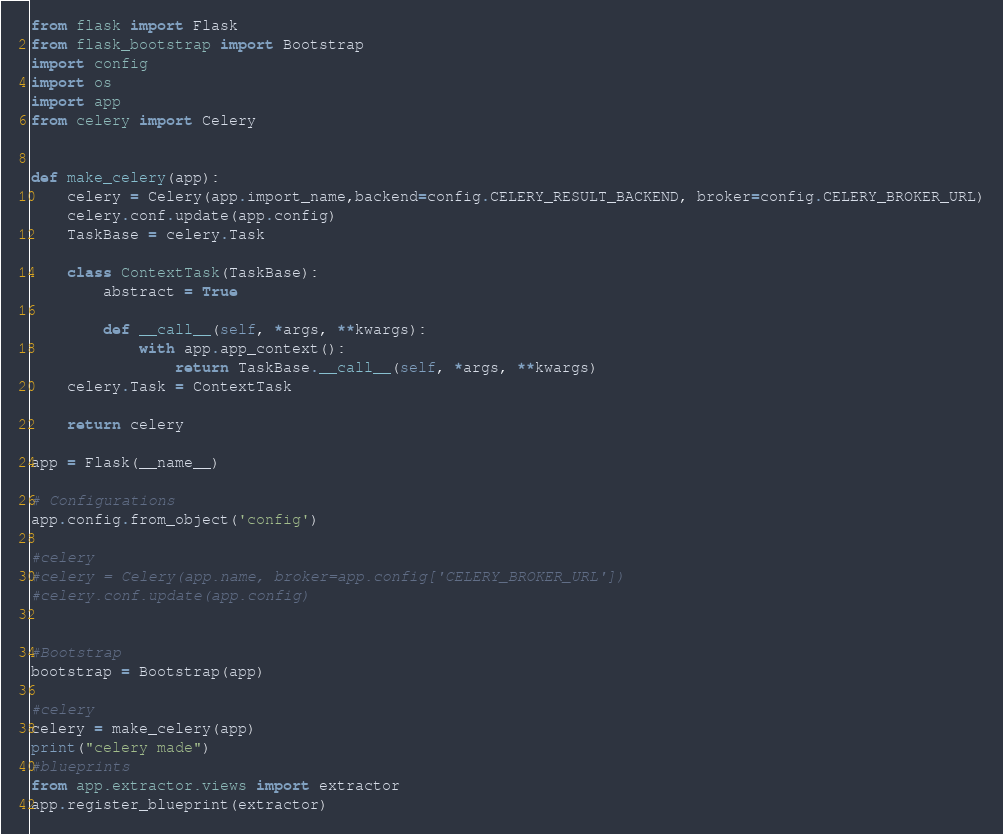Convert code to text. <code><loc_0><loc_0><loc_500><loc_500><_Python_>from flask import Flask
from flask_bootstrap import Bootstrap
import config
import os
import app
from celery import Celery


def make_celery(app):
    celery = Celery(app.import_name,backend=config.CELERY_RESULT_BACKEND, broker=config.CELERY_BROKER_URL)
    celery.conf.update(app.config)
    TaskBase = celery.Task

    class ContextTask(TaskBase):
        abstract = True

        def __call__(self, *args, **kwargs):
            with app.app_context():
                return TaskBase.__call__(self, *args, **kwargs)
    celery.Task = ContextTask

    return celery

app = Flask(__name__)

# Configurations
app.config.from_object('config')

#celery
#celery = Celery(app.name, broker=app.config['CELERY_BROKER_URL'])
#celery.conf.update(app.config)


#Bootstrap
bootstrap = Bootstrap(app)

#celery
celery = make_celery(app)
print("celery made")
#blueprints
from app.extractor.views import extractor
app.register_blueprint(extractor)



</code> 